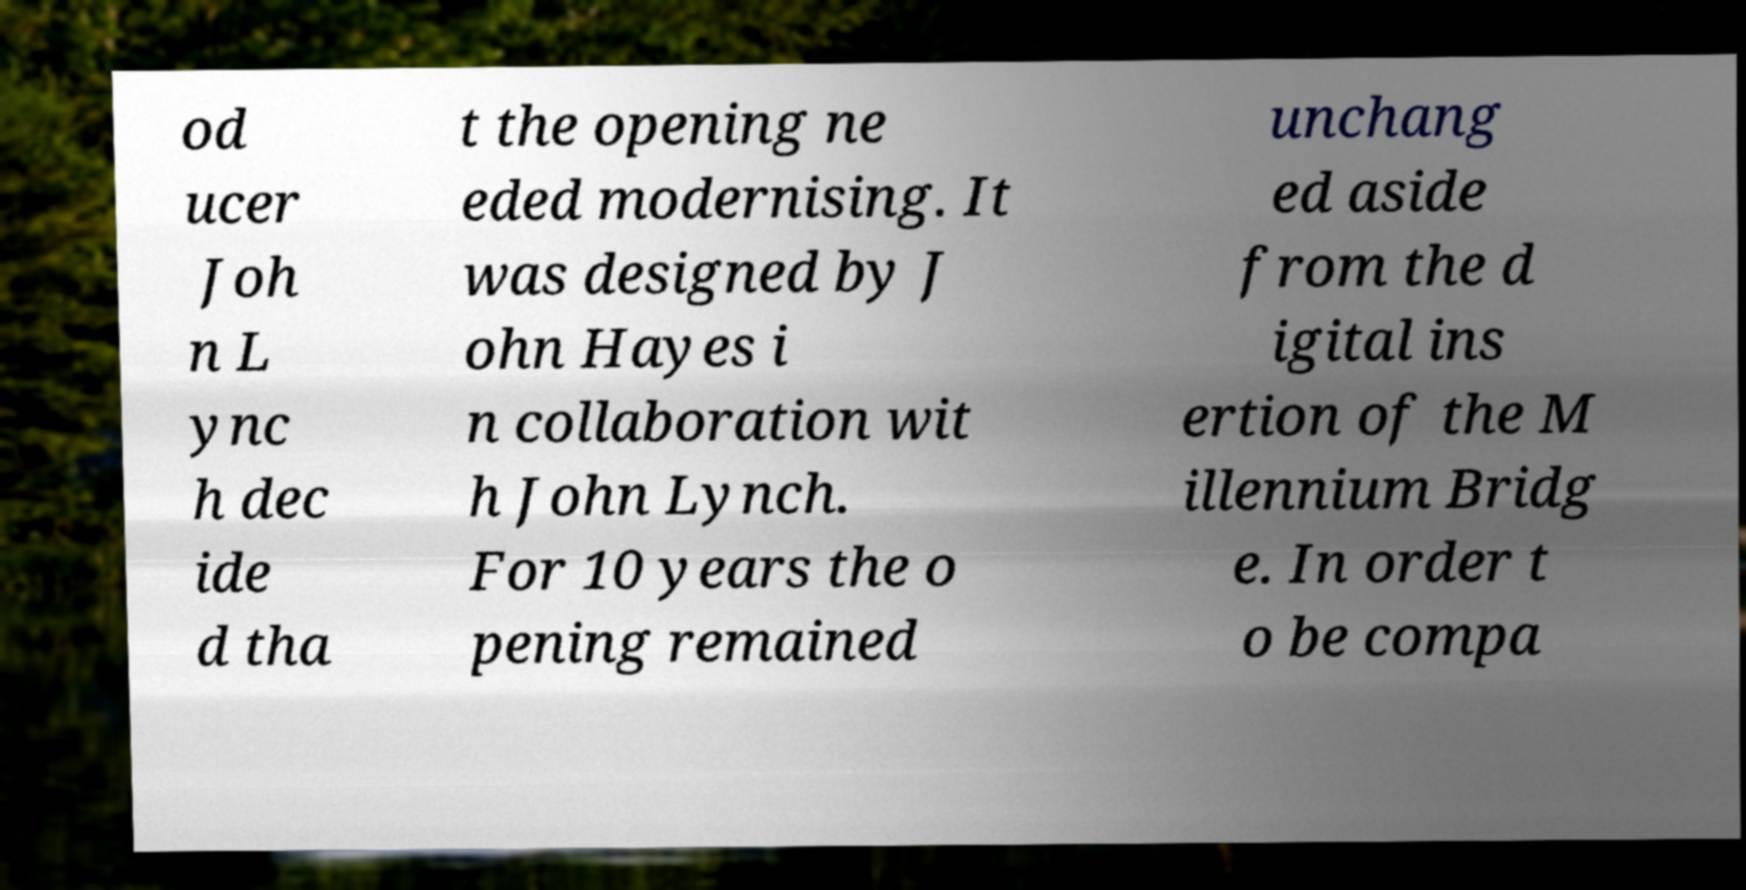Can you accurately transcribe the text from the provided image for me? od ucer Joh n L ync h dec ide d tha t the opening ne eded modernising. It was designed by J ohn Hayes i n collaboration wit h John Lynch. For 10 years the o pening remained unchang ed aside from the d igital ins ertion of the M illennium Bridg e. In order t o be compa 